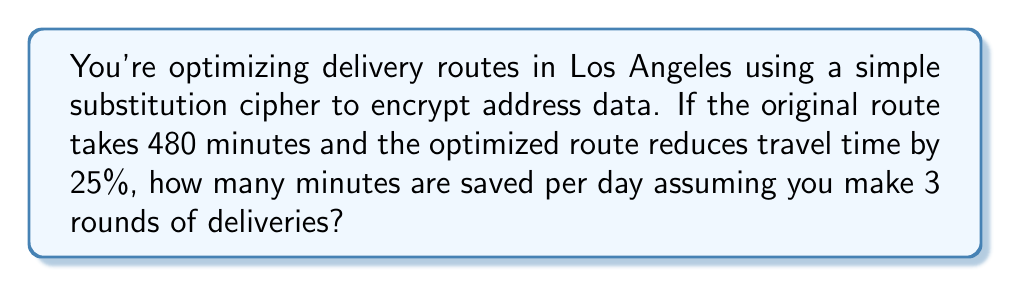Provide a solution to this math problem. Let's break this down step-by-step:

1) First, we need to calculate the time saved for one route:
   - Original route time: 480 minutes
   - Reduction percentage: 25% = 0.25
   - Time saved = Original time × Reduction percentage
   $$ 480 \times 0.25 = 120 \text{ minutes} $$

2) Now, we know that 120 minutes are saved per route.

3) The question states that you make 3 rounds of deliveries per day:
   - Time saved per day = Time saved per route × Number of routes
   $$ 120 \times 3 = 360 \text{ minutes} $$

Therefore, by optimizing the delivery routes using basic encryption principles, you save 360 minutes per day.
Answer: 360 minutes 